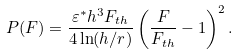<formula> <loc_0><loc_0><loc_500><loc_500>P ( F ) = \frac { \varepsilon ^ { \ast } h ^ { 3 } F _ { t h } } { 4 \ln ( h / r ) } \left ( \frac { F } { F _ { t h } } - 1 \right ) ^ { 2 } .</formula> 